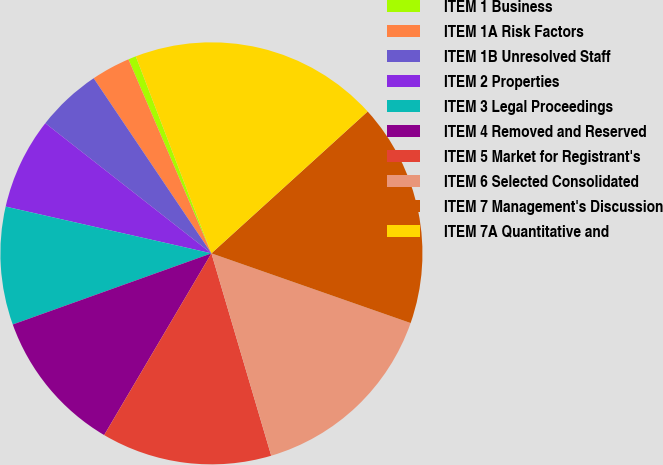Convert chart. <chart><loc_0><loc_0><loc_500><loc_500><pie_chart><fcel>ITEM 1 Business<fcel>ITEM 1A Risk Factors<fcel>ITEM 1B Unresolved Staff<fcel>ITEM 2 Properties<fcel>ITEM 3 Legal Proceedings<fcel>ITEM 4 Removed and Reserved<fcel>ITEM 5 Market for Registrant's<fcel>ITEM 6 Selected Consolidated<fcel>ITEM 7 Management's Discussion<fcel>ITEM 7A Quantitative and<nl><fcel>0.6%<fcel>2.99%<fcel>5.0%<fcel>7.02%<fcel>9.03%<fcel>11.04%<fcel>13.06%<fcel>15.07%<fcel>17.09%<fcel>19.1%<nl></chart> 